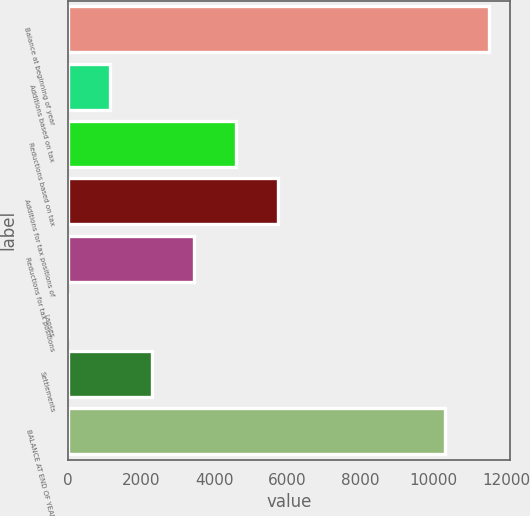Convert chart. <chart><loc_0><loc_0><loc_500><loc_500><bar_chart><fcel>Balance at beginning of year<fcel>Additions based on tax<fcel>Reductions based on tax<fcel>Additions for tax positions of<fcel>Reductions for tax positions<fcel>Lapses<fcel>Settlements<fcel>BALANCE AT END OF YEAR<nl><fcel>11515<fcel>1153.32<fcel>4607.22<fcel>5758.52<fcel>3455.92<fcel>2.02<fcel>2304.62<fcel>10322<nl></chart> 